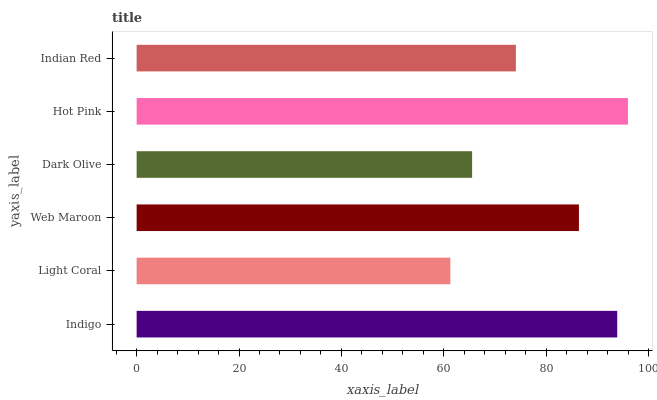Is Light Coral the minimum?
Answer yes or no. Yes. Is Hot Pink the maximum?
Answer yes or no. Yes. Is Web Maroon the minimum?
Answer yes or no. No. Is Web Maroon the maximum?
Answer yes or no. No. Is Web Maroon greater than Light Coral?
Answer yes or no. Yes. Is Light Coral less than Web Maroon?
Answer yes or no. Yes. Is Light Coral greater than Web Maroon?
Answer yes or no. No. Is Web Maroon less than Light Coral?
Answer yes or no. No. Is Web Maroon the high median?
Answer yes or no. Yes. Is Indian Red the low median?
Answer yes or no. Yes. Is Dark Olive the high median?
Answer yes or no. No. Is Indigo the low median?
Answer yes or no. No. 